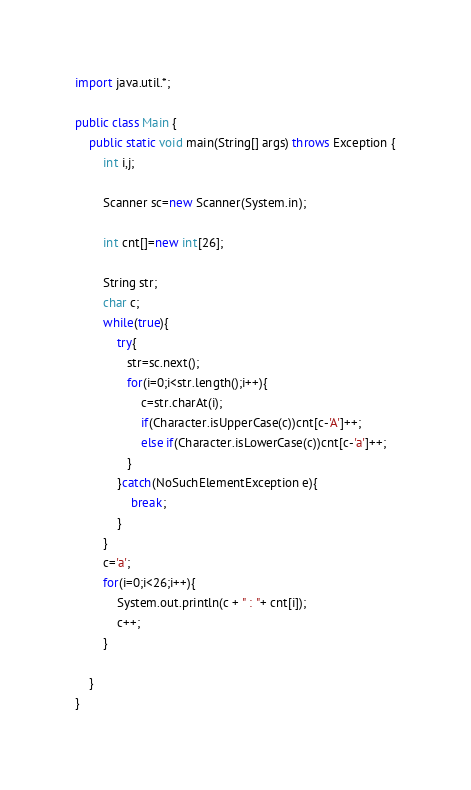<code> <loc_0><loc_0><loc_500><loc_500><_Java_>import java.util.*;

public class Main {
    public static void main(String[] args) throws Exception {
        int i,j;
        
        Scanner sc=new Scanner(System.in);
        
        int cnt[]=new int[26];
        
        String str;
        char c;
        while(true){
            try{
               str=sc.next();
               for(i=0;i<str.length();i++){
                   c=str.charAt(i);
                   if(Character.isUpperCase(c))cnt[c-'A']++;
                   else if(Character.isLowerCase(c))cnt[c-'a']++;
               }
            }catch(NoSuchElementException e){
                break;
            }
        }
        c='a';
        for(i=0;i<26;i++){
            System.out.println(c + " : "+ cnt[i]);
            c++;
        }
        
    }
}

</code> 